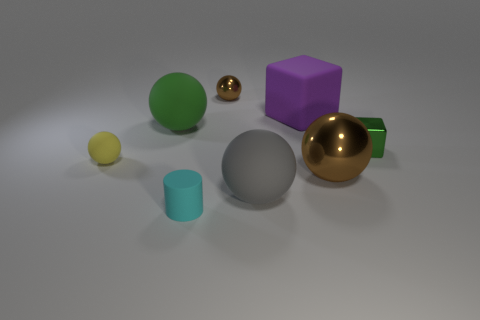The small ball behind the small green block is what color?
Offer a very short reply. Brown. There is a tiny object that is behind the tiny cyan cylinder and in front of the tiny green block; what material is it made of?
Your answer should be compact. Rubber. What number of small brown metal balls are to the left of the small ball in front of the green shiny object?
Offer a very short reply. 0. What is the shape of the small yellow object?
Ensure brevity in your answer.  Sphere. There is a small yellow object that is the same material as the purple block; what shape is it?
Your response must be concise. Sphere. Do the brown thing behind the yellow rubber object and the gray object have the same shape?
Your answer should be compact. Yes. There is a green object that is to the right of the small brown shiny object; what shape is it?
Your answer should be very brief. Cube. There is a tiny object that is the same color as the big metallic sphere; what is its shape?
Provide a succinct answer. Sphere. What number of purple metallic balls are the same size as the yellow sphere?
Offer a terse response. 0. The big matte block has what color?
Provide a succinct answer. Purple. 